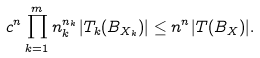Convert formula to latex. <formula><loc_0><loc_0><loc_500><loc_500>c ^ { n } \prod ^ { m } _ { k = 1 } n _ { k } ^ { n _ { k } } | T _ { k } ( B _ { X _ { k } } ) | \leq n ^ { n } | T ( B _ { X } ) | .</formula> 